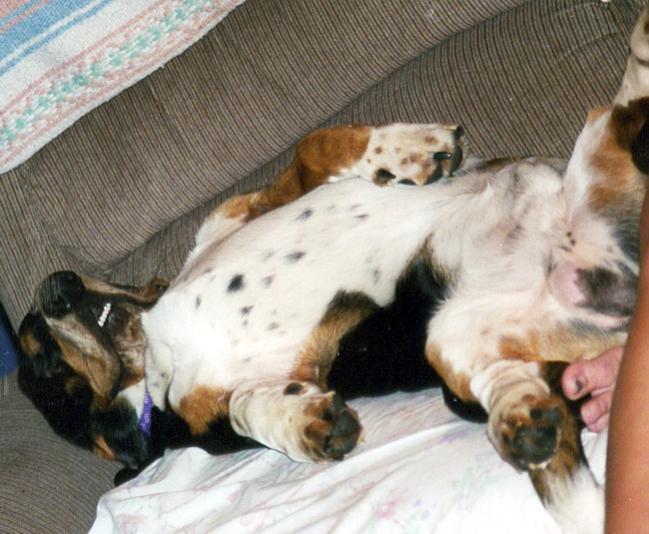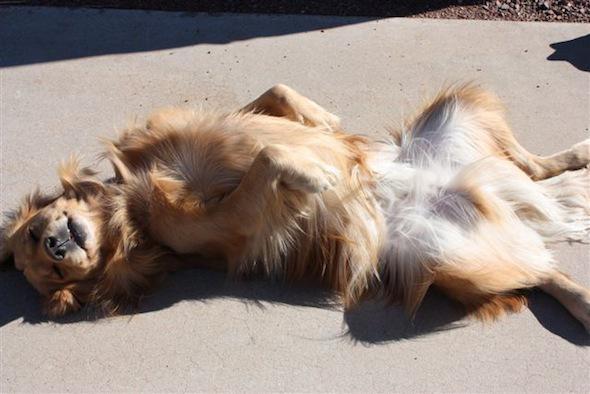The first image is the image on the left, the second image is the image on the right. Evaluate the accuracy of this statement regarding the images: "In one of the images there is a Basset Hound sleeping on its tummy.". Is it true? Answer yes or no. No. The first image is the image on the left, the second image is the image on the right. Assess this claim about the two images: "Each image contains one basset hound, and one hound lies on his back while the other hound lies on his stomach with his head flat.". Correct or not? Answer yes or no. No. 